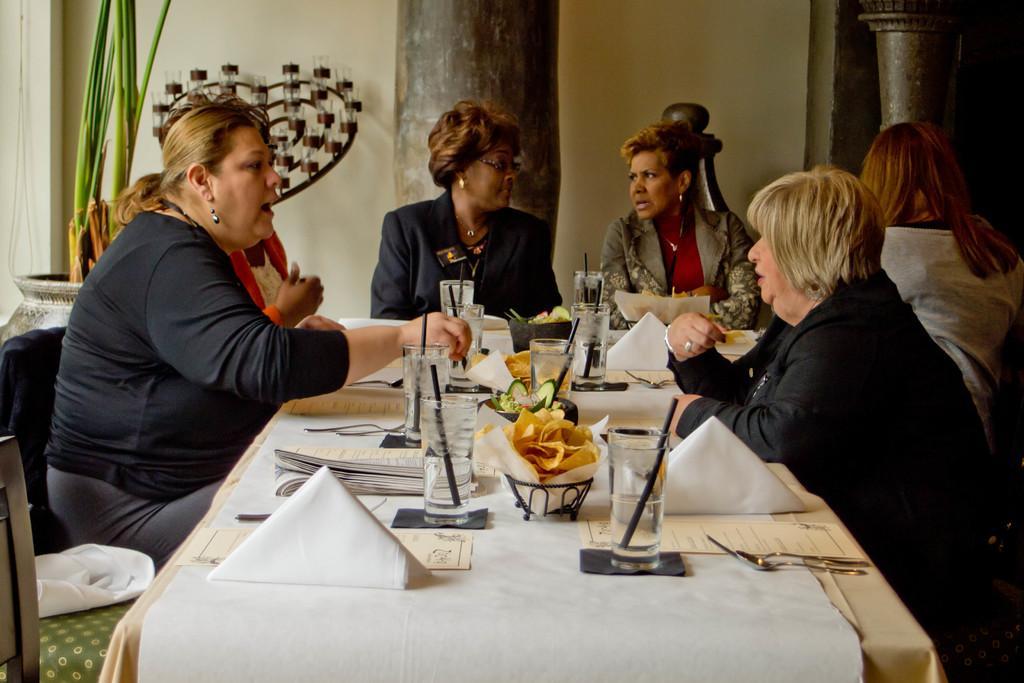Describe this image in one or two sentences. In this picture there are a group of women sitting, they have a table in front of them, with some food, water glasses, food menu etc. 